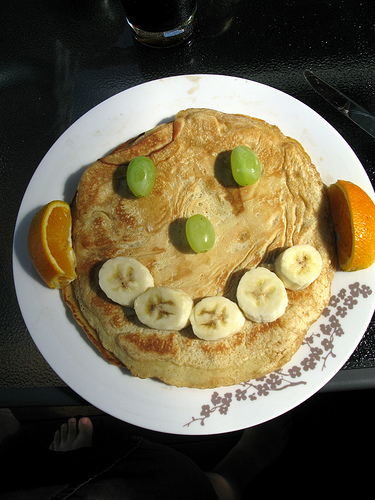<image>
Can you confirm if the food is in the plate? Yes. The food is contained within or inside the plate, showing a containment relationship. Is there a plate in front of the food? No. The plate is not in front of the food. The spatial positioning shows a different relationship between these objects. 